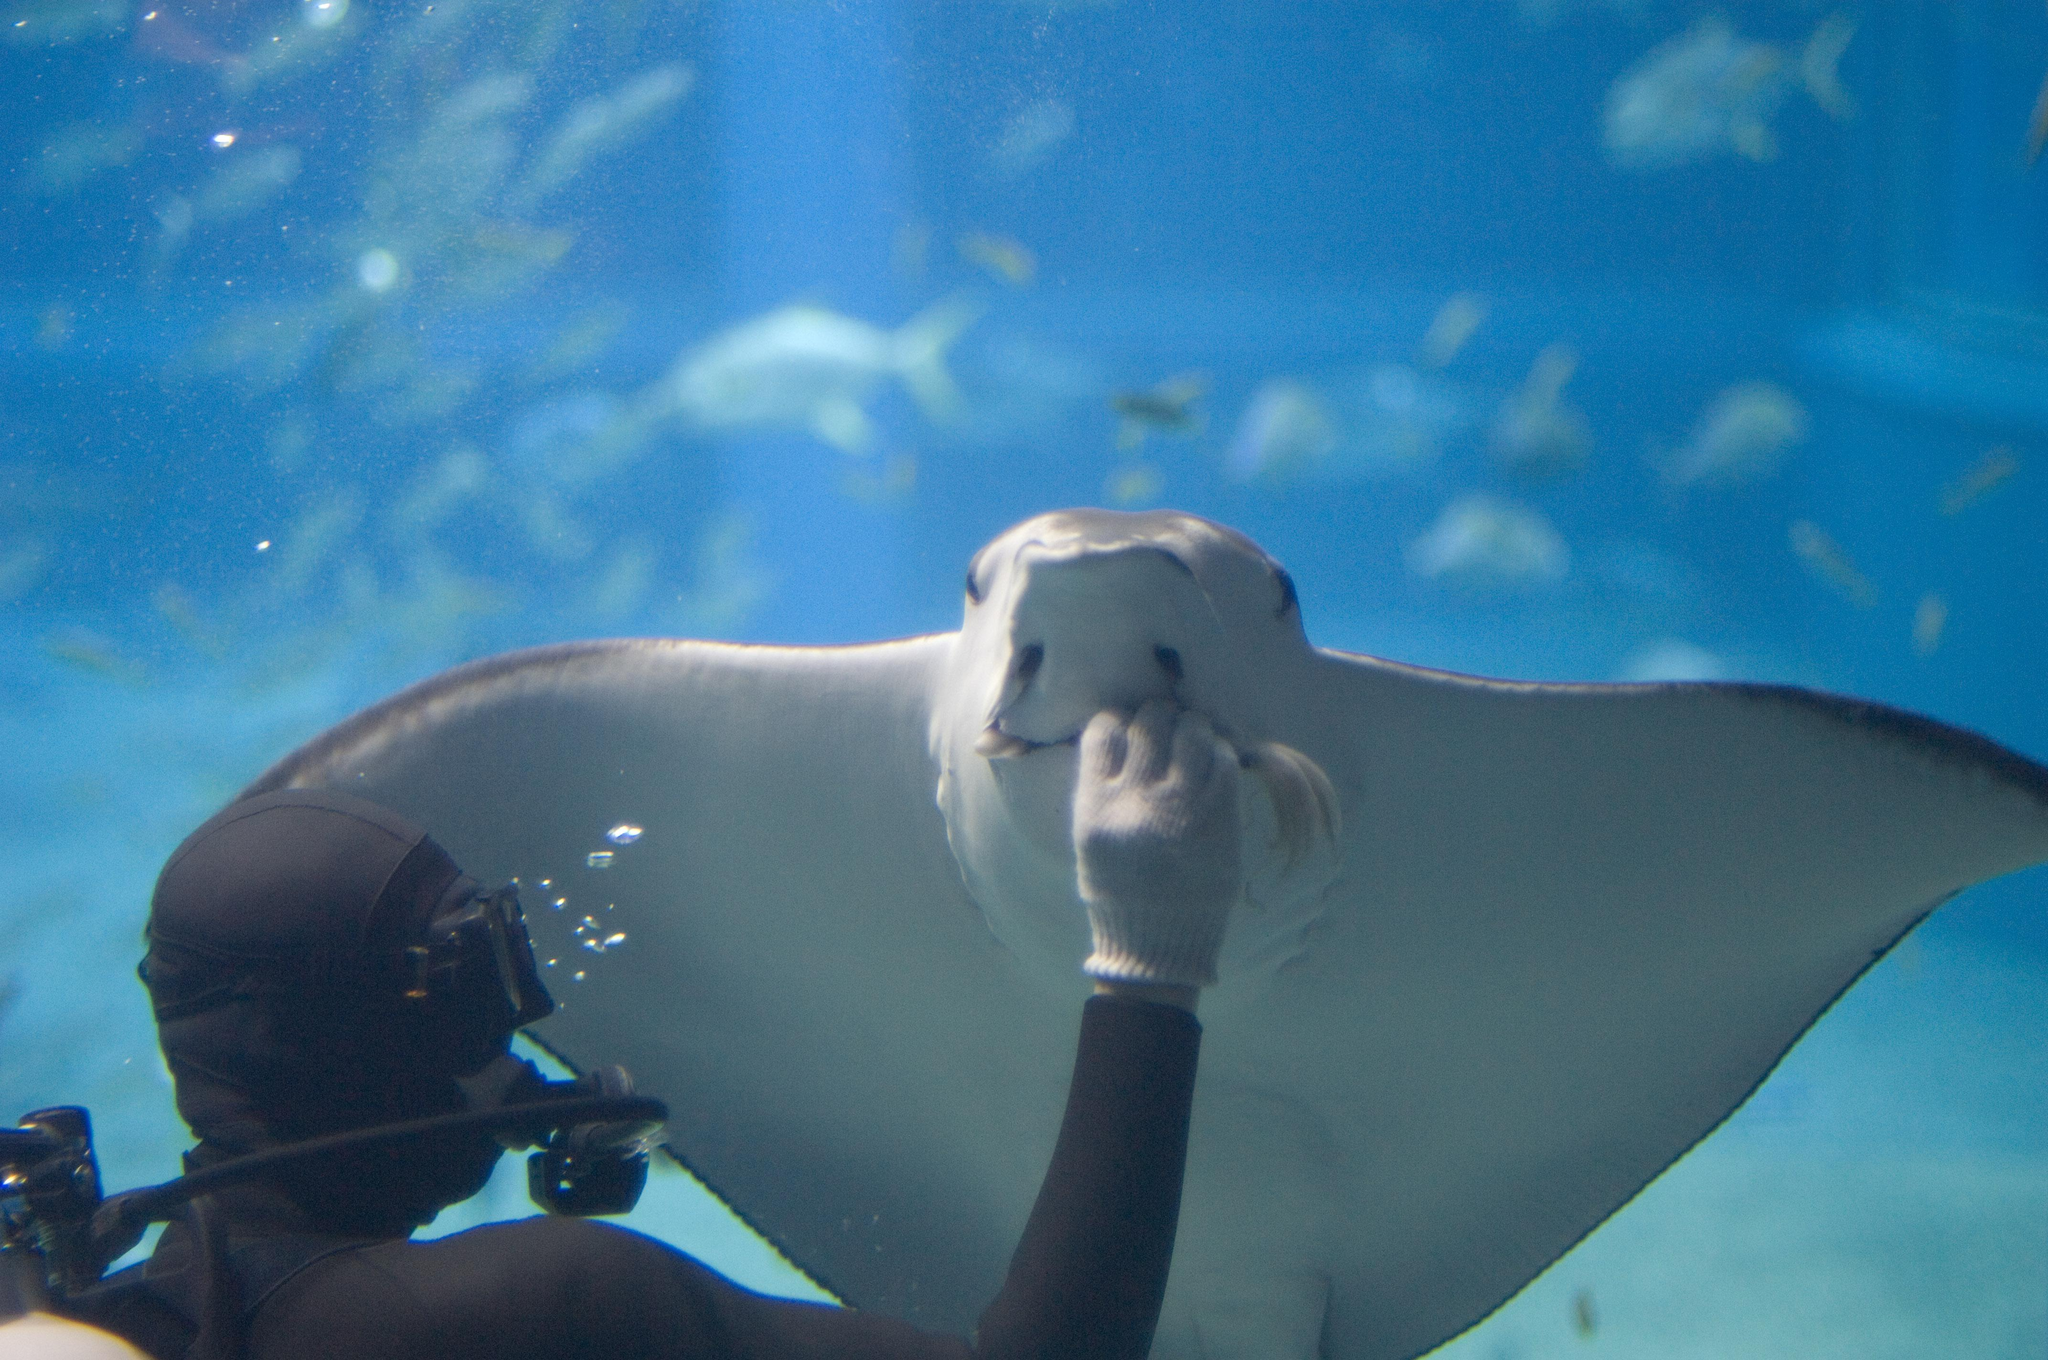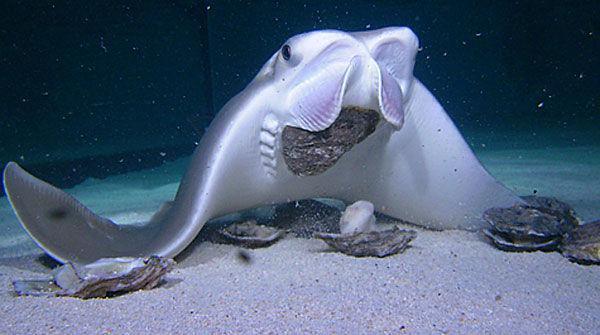The first image is the image on the left, the second image is the image on the right. Considering the images on both sides, is "A person is in the water near the sting rays." valid? Answer yes or no. Yes. The first image is the image on the left, the second image is the image on the right. For the images displayed, is the sentence "A human hand is near the underside of a stingray in one image." factually correct? Answer yes or no. Yes. 